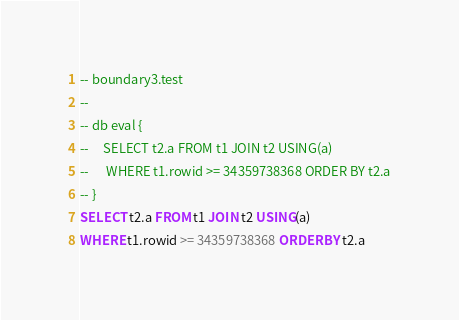Convert code to text. <code><loc_0><loc_0><loc_500><loc_500><_SQL_>-- boundary3.test
-- 
-- db eval {
--     SELECT t2.a FROM t1 JOIN t2 USING(a)
--      WHERE t1.rowid >= 34359738368 ORDER BY t2.a
-- }
SELECT t2.a FROM t1 JOIN t2 USING(a)
WHERE t1.rowid >= 34359738368 ORDER BY t2.a</code> 